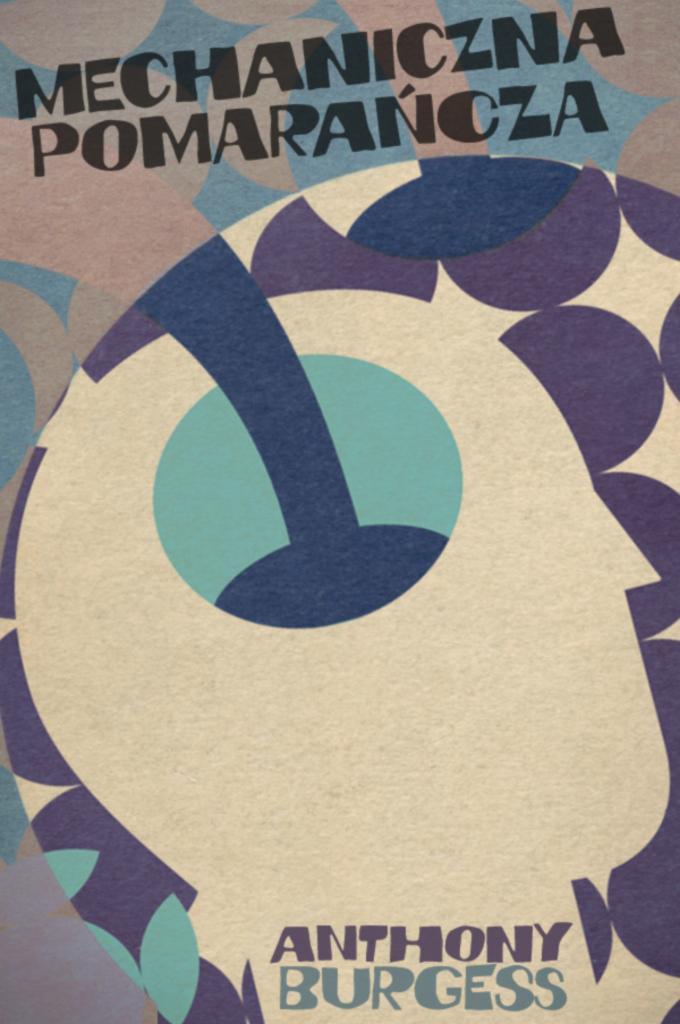What can be observed in terms of visual elements in the image? There are color patterns visible in the image. Is there any text present in the image? Yes, there is text visible in the middle of the image. What type of pain is being expressed by the garden in the image? There is no garden present in the image, and therefore no pain can be expressed by it. 